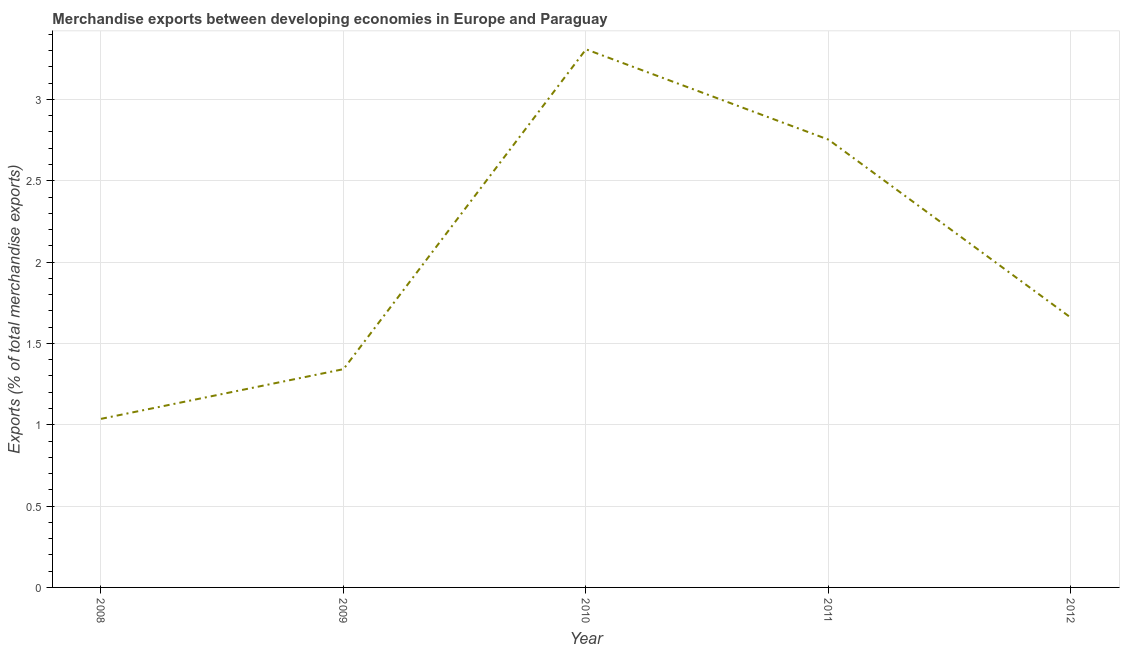What is the merchandise exports in 2010?
Give a very brief answer. 3.31. Across all years, what is the maximum merchandise exports?
Your answer should be very brief. 3.31. Across all years, what is the minimum merchandise exports?
Provide a short and direct response. 1.04. In which year was the merchandise exports maximum?
Give a very brief answer. 2010. In which year was the merchandise exports minimum?
Provide a succinct answer. 2008. What is the sum of the merchandise exports?
Your response must be concise. 10.1. What is the difference between the merchandise exports in 2010 and 2011?
Your response must be concise. 0.56. What is the average merchandise exports per year?
Offer a very short reply. 2.02. What is the median merchandise exports?
Ensure brevity in your answer.  1.66. What is the ratio of the merchandise exports in 2008 to that in 2010?
Offer a very short reply. 0.31. What is the difference between the highest and the second highest merchandise exports?
Keep it short and to the point. 0.56. What is the difference between the highest and the lowest merchandise exports?
Offer a terse response. 2.27. Does the merchandise exports monotonically increase over the years?
Provide a short and direct response. No. How many lines are there?
Keep it short and to the point. 1. How many years are there in the graph?
Provide a short and direct response. 5. Does the graph contain any zero values?
Your answer should be compact. No. What is the title of the graph?
Offer a very short reply. Merchandise exports between developing economies in Europe and Paraguay. What is the label or title of the Y-axis?
Offer a very short reply. Exports (% of total merchandise exports). What is the Exports (% of total merchandise exports) in 2008?
Your answer should be compact. 1.04. What is the Exports (% of total merchandise exports) in 2009?
Keep it short and to the point. 1.34. What is the Exports (% of total merchandise exports) of 2010?
Your answer should be compact. 3.31. What is the Exports (% of total merchandise exports) of 2011?
Your answer should be very brief. 2.75. What is the Exports (% of total merchandise exports) in 2012?
Provide a succinct answer. 1.66. What is the difference between the Exports (% of total merchandise exports) in 2008 and 2009?
Keep it short and to the point. -0.31. What is the difference between the Exports (% of total merchandise exports) in 2008 and 2010?
Offer a terse response. -2.27. What is the difference between the Exports (% of total merchandise exports) in 2008 and 2011?
Offer a very short reply. -1.72. What is the difference between the Exports (% of total merchandise exports) in 2008 and 2012?
Keep it short and to the point. -0.62. What is the difference between the Exports (% of total merchandise exports) in 2009 and 2010?
Offer a very short reply. -1.97. What is the difference between the Exports (% of total merchandise exports) in 2009 and 2011?
Ensure brevity in your answer.  -1.41. What is the difference between the Exports (% of total merchandise exports) in 2009 and 2012?
Keep it short and to the point. -0.32. What is the difference between the Exports (% of total merchandise exports) in 2010 and 2011?
Give a very brief answer. 0.56. What is the difference between the Exports (% of total merchandise exports) in 2010 and 2012?
Your answer should be compact. 1.65. What is the difference between the Exports (% of total merchandise exports) in 2011 and 2012?
Give a very brief answer. 1.1. What is the ratio of the Exports (% of total merchandise exports) in 2008 to that in 2009?
Make the answer very short. 0.77. What is the ratio of the Exports (% of total merchandise exports) in 2008 to that in 2010?
Ensure brevity in your answer.  0.31. What is the ratio of the Exports (% of total merchandise exports) in 2008 to that in 2011?
Give a very brief answer. 0.38. What is the ratio of the Exports (% of total merchandise exports) in 2009 to that in 2010?
Your answer should be very brief. 0.41. What is the ratio of the Exports (% of total merchandise exports) in 2009 to that in 2011?
Your response must be concise. 0.49. What is the ratio of the Exports (% of total merchandise exports) in 2009 to that in 2012?
Offer a terse response. 0.81. What is the ratio of the Exports (% of total merchandise exports) in 2010 to that in 2011?
Provide a short and direct response. 1.2. What is the ratio of the Exports (% of total merchandise exports) in 2010 to that in 2012?
Offer a terse response. 2. What is the ratio of the Exports (% of total merchandise exports) in 2011 to that in 2012?
Offer a terse response. 1.66. 